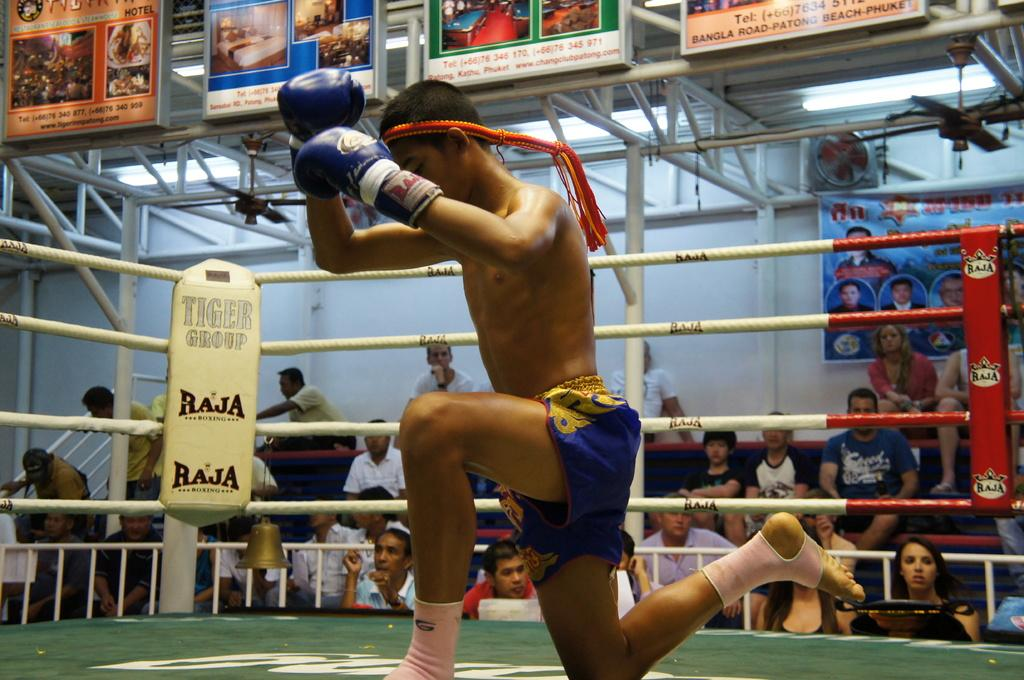<image>
Relay a brief, clear account of the picture shown. A man is kneeling in a boxing ring that has the word baja on the corner 